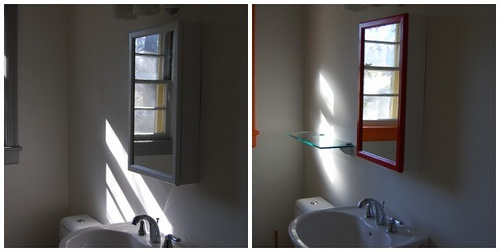Describe the objects in this image and their specific colors. I can see sink in white, black, and gray tones, sink in white, gray, black, and darkgray tones, toilet in white, gray, darkgray, and black tones, and toilet in white, gray, and black tones in this image. 